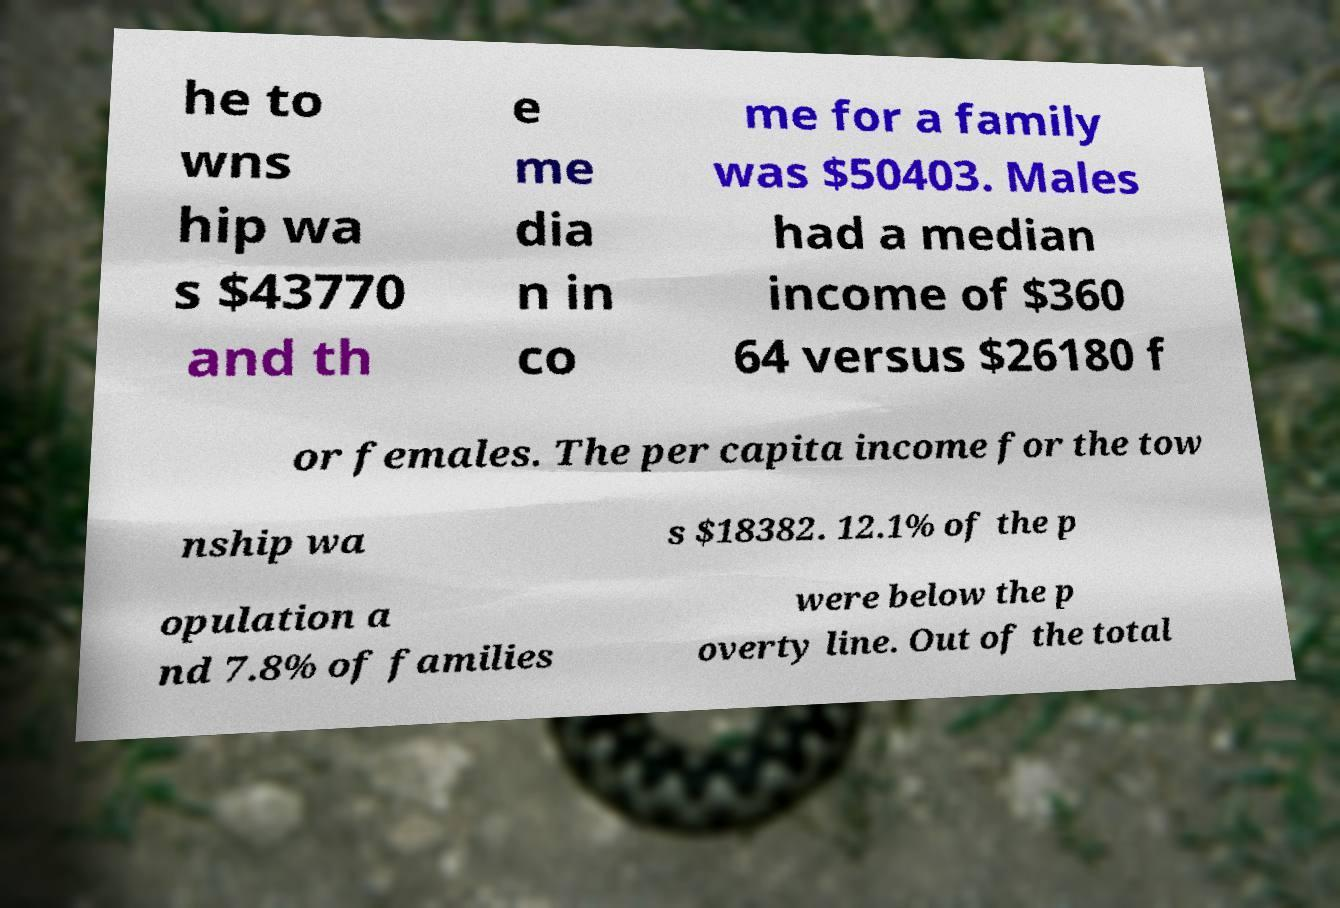Can you accurately transcribe the text from the provided image for me? he to wns hip wa s $43770 and th e me dia n in co me for a family was $50403. Males had a median income of $360 64 versus $26180 f or females. The per capita income for the tow nship wa s $18382. 12.1% of the p opulation a nd 7.8% of families were below the p overty line. Out of the total 